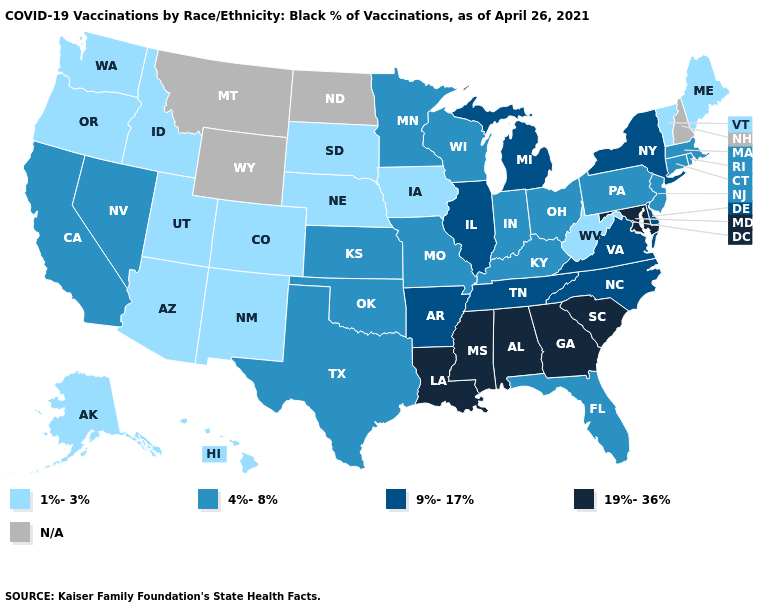What is the value of Rhode Island?
Quick response, please. 4%-8%. Does New Jersey have the lowest value in the USA?
Give a very brief answer. No. Among the states that border Massachusetts , which have the highest value?
Keep it brief. New York. What is the highest value in the USA?
Answer briefly. 19%-36%. What is the value of Massachusetts?
Give a very brief answer. 4%-8%. Name the states that have a value in the range 9%-17%?
Write a very short answer. Arkansas, Delaware, Illinois, Michigan, New York, North Carolina, Tennessee, Virginia. What is the value of Utah?
Quick response, please. 1%-3%. Among the states that border South Dakota , does Nebraska have the highest value?
Be succinct. No. What is the lowest value in the USA?
Quick response, please. 1%-3%. What is the highest value in states that border Maryland?
Answer briefly. 9%-17%. Which states hav the highest value in the MidWest?
Write a very short answer. Illinois, Michigan. What is the value of Utah?
Be succinct. 1%-3%. 